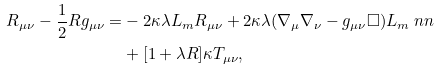Convert formula to latex. <formula><loc_0><loc_0><loc_500><loc_500>R _ { \mu \nu } - \frac { 1 } { 2 } R g _ { \mu \nu } = & - 2 \kappa \lambda L _ { m } R _ { \mu \nu } + 2 \kappa \lambda ( \nabla _ { \mu } \nabla _ { \nu } - g _ { \mu \nu } \Box ) L _ { m } \ n n \\ & + [ 1 + \lambda R ] \kappa T _ { \mu \nu } ,</formula> 